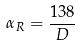Convert formula to latex. <formula><loc_0><loc_0><loc_500><loc_500>\alpha _ { R } = \frac { 1 3 8 } { D }</formula> 